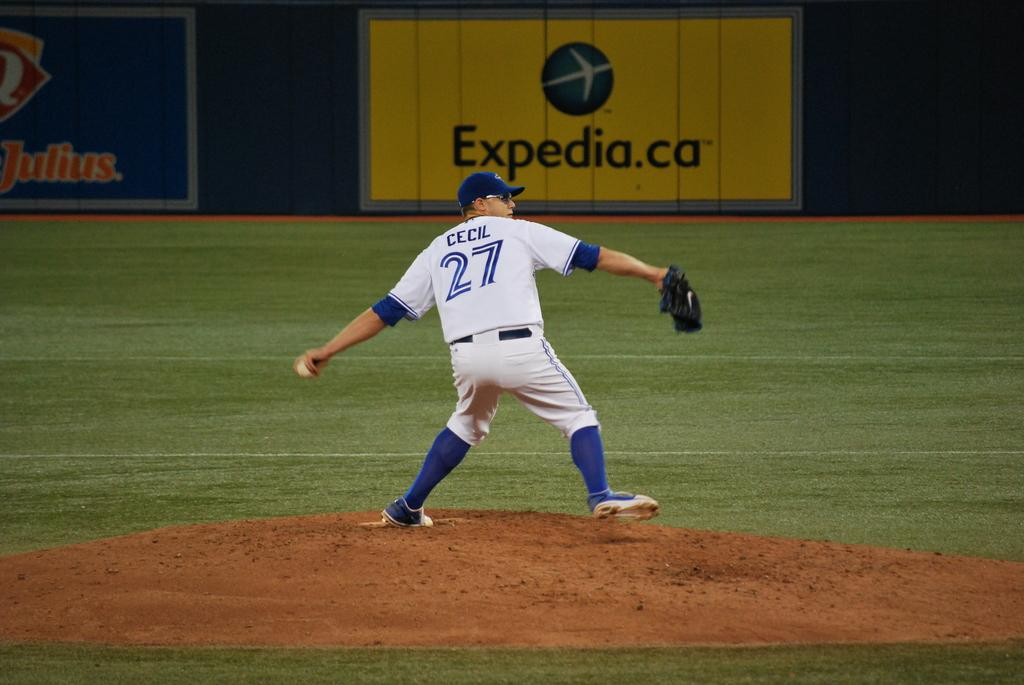Provide a one-sentence caption for the provided image. Baseball player named Cecil and number 27 getting ready to throw the ball. 